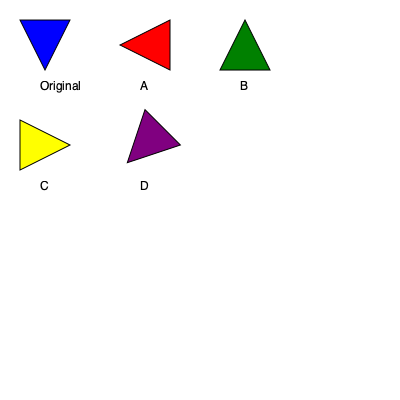Which of the rotated team logos (A, B, C, or D) matches the original logo when rotated 180 degrees? To solve this problem, we need to mentally rotate each of the given logos by 180 degrees and compare them to the original logo. Let's go through each option:

1. Logo A: This logo is rotated 90 degrees clockwise from the original. If we rotate it 180 degrees, it would point downwards, which doesn't match the original.

2. Logo B: This logo is already rotated 180 degrees from the original. If we rotate it another 180 degrees, it would return to the original position, matching the given logo.

3. Logo C: This logo is rotated 270 degrees clockwise (or 90 degrees counterclockwise) from the original. Rotating it 180 degrees would make it point to the right, which doesn't match the original.

4. Logo D: This logo is rotated 45 degrees clockwise from the original. Rotating it 180 degrees would make it point downwards and to the left, which doesn't match the original.

Therefore, the logo that matches the original when rotated 180 degrees is Logo B.
Answer: B 